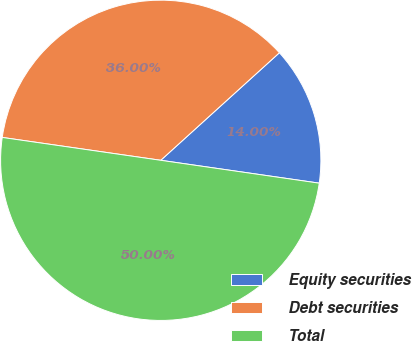Convert chart to OTSL. <chart><loc_0><loc_0><loc_500><loc_500><pie_chart><fcel>Equity securities<fcel>Debt securities<fcel>Total<nl><fcel>14.0%<fcel>36.0%<fcel>50.0%<nl></chart> 